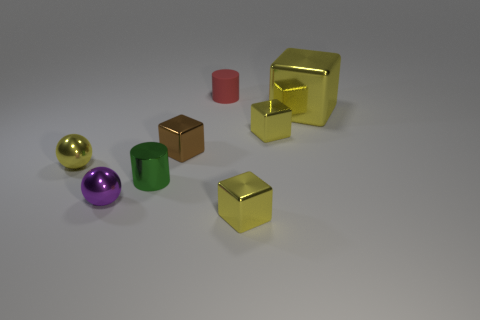What number of other objects are the same size as the matte object?
Ensure brevity in your answer.  6. What is the size of the block on the left side of the red object?
Your answer should be very brief. Small. There is a large yellow object that is the same material as the tiny purple ball; what is its shape?
Ensure brevity in your answer.  Cube. Is there any other thing that is the same color as the matte cylinder?
Ensure brevity in your answer.  No. There is a block that is in front of the yellow shiny object that is on the left side of the rubber cylinder; what color is it?
Your answer should be compact. Yellow. What number of tiny objects are either yellow shiny cubes or yellow shiny objects?
Make the answer very short. 3. What is the material of the big object that is the same shape as the tiny brown shiny object?
Offer a terse response. Metal. Is there anything else that has the same material as the red cylinder?
Offer a very short reply. No. The rubber cylinder has what color?
Offer a very short reply. Red. Does the small metal cylinder have the same color as the tiny matte object?
Provide a short and direct response. No. 